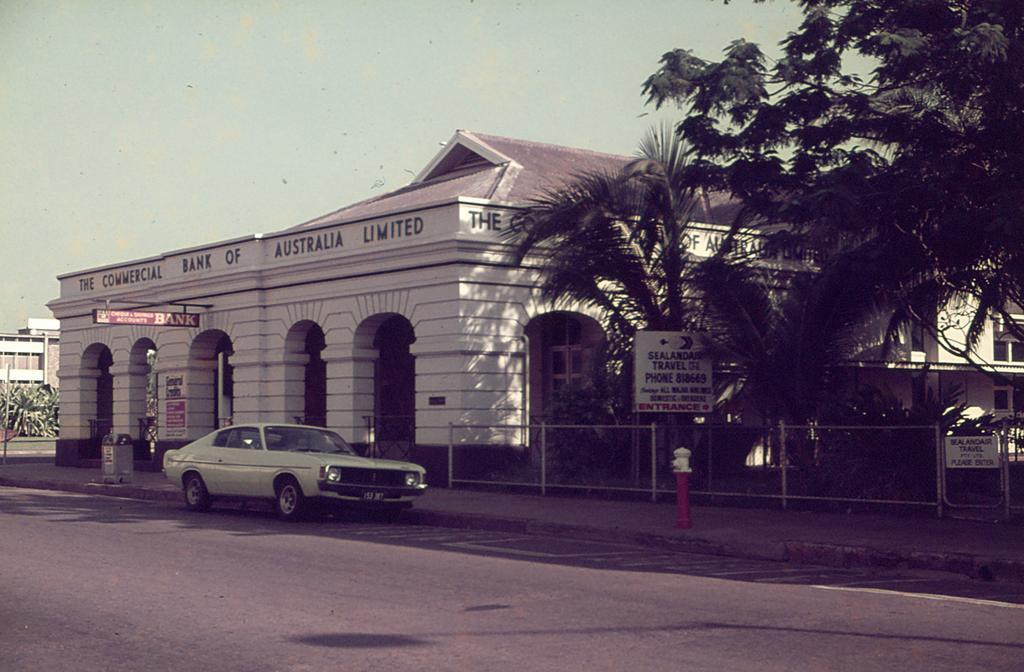Please provide a concise description of this image. In this picture I can see buildings, trees and few boards with some text and I can see text on the wall and a car on the road. I can see a fire hydrant and a dustbin on the sidewalk and I can see a blue sky. 